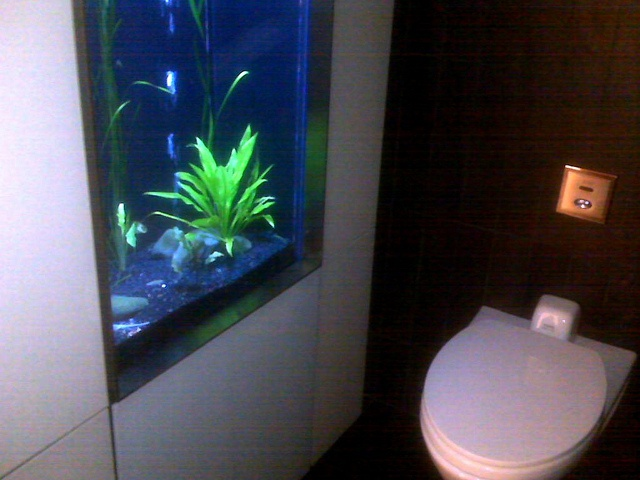Describe the objects in this image and their specific colors. I can see a toilet in lavender, darkgray, gray, and lightpink tones in this image. 